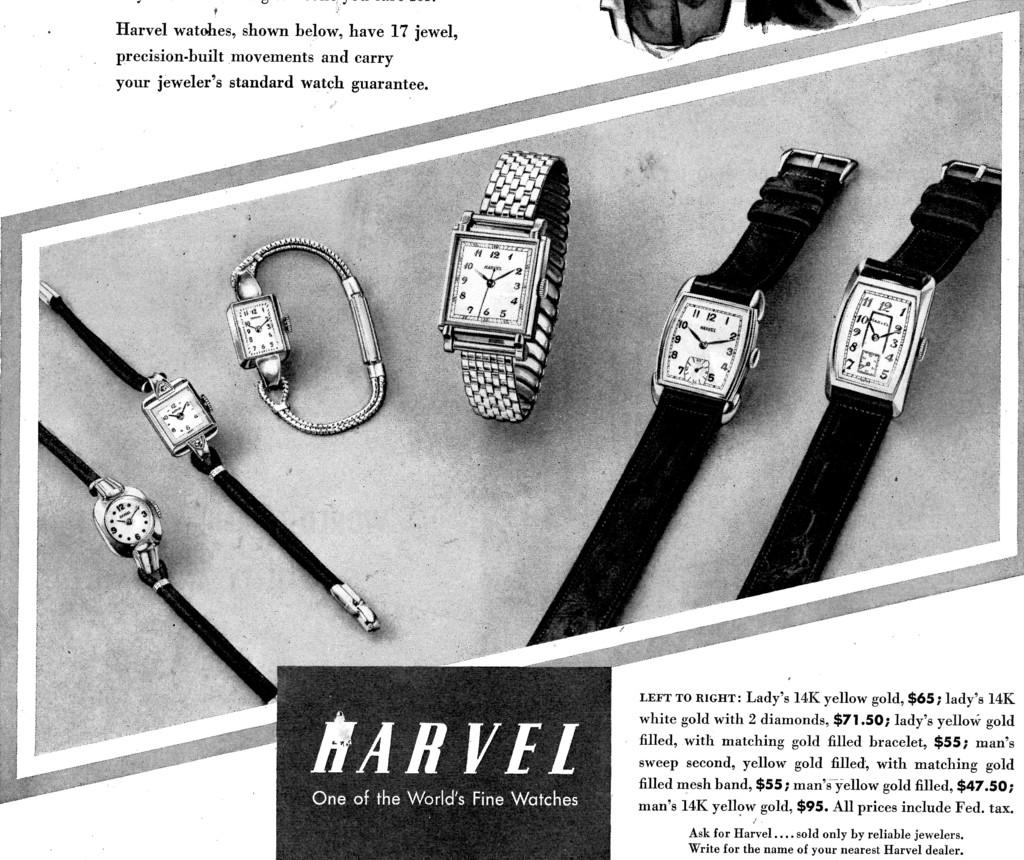<image>
Summarize the visual content of the image. A black and white advertisement for Harvel, one of the world's fine watches, shows several different style of watches. 